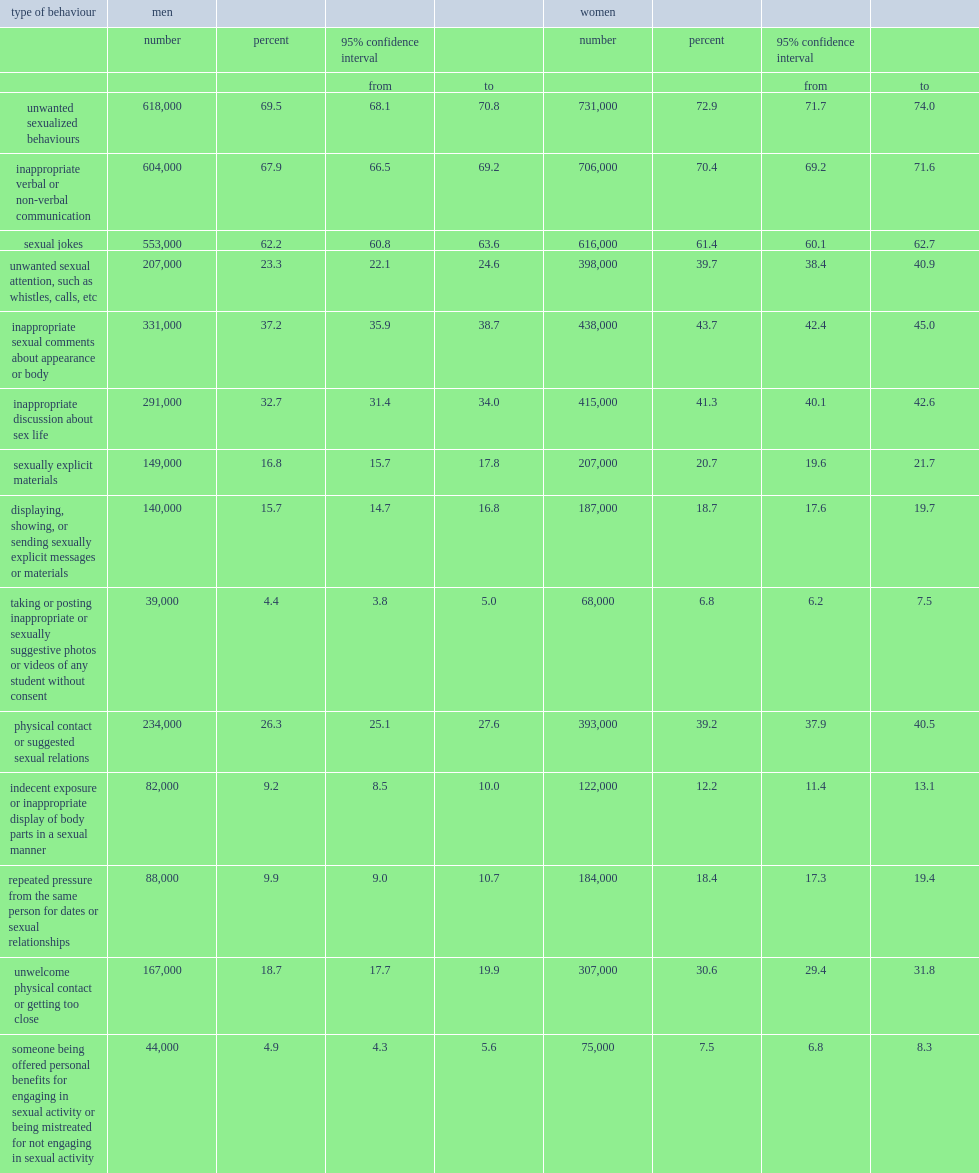On the whole, which gender was more likely to have either witnessed or experienced these behaviours, men or women? Women. 